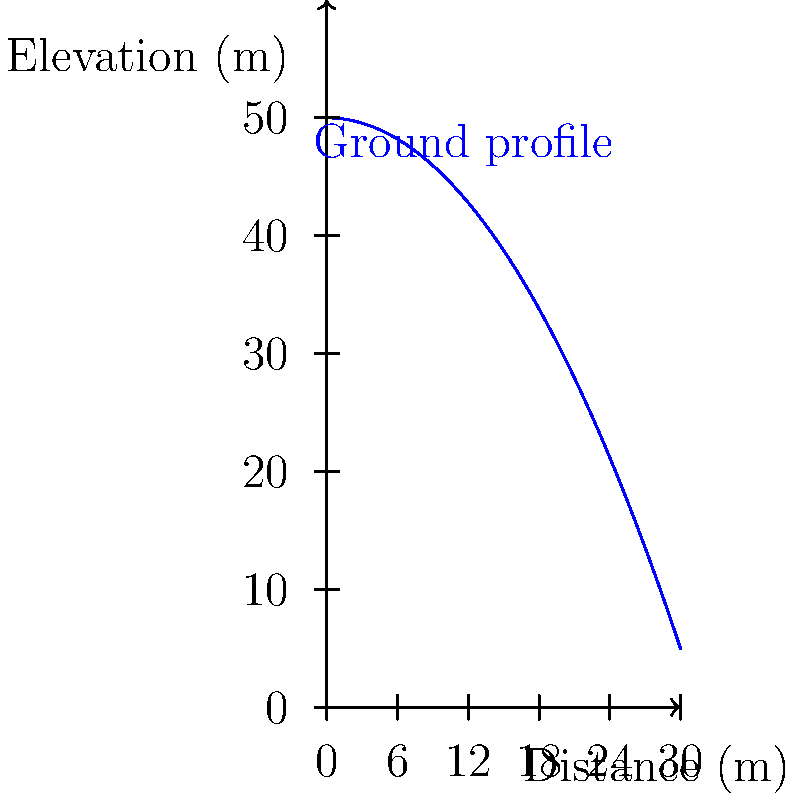A section of the Qosh Tepa Canal needs to be excavated. The longitudinal profile of the ground is shown in the graph above. The canal will have a constant bottom width of 5 meters and side slopes of 1:1. If the canal needs to be excavated to a depth of 40 meters at the deepest point, what is the total volume of soil to be excavated for a 30-meter long section of the canal? To calculate the volume of soil to be excavated, we need to follow these steps:

1) The ground profile is given by the equation: $y = 50 - 0.05x^2$

2) The canal bottom is 40 meters below the highest point, so its equation is: $y = 10$

3) We need to find the area between these two curves:
   $A = \int_0^{30} (50 - 0.05x^2 - 10) dx$
   $A = \int_0^{30} (40 - 0.05x^2) dx$
   $A = [40x - \frac{0.05x^3}{3}]_0^{30}$
   $A = (1200 - 450) - 0 = 750$ square meters

4) This is the cross-sectional area at the deepest point. The average cross-sectional area will be half of this: 375 square meters

5) The volume of a prismoidal shape (like our canal section) is given by the average cross-sectional area multiplied by the length:
   $V = 375 * 30 = 11,250$ cubic meters

6) However, this is just the rectangular part. We need to add the volume of the triangular sections on each side due to the 1:1 slope.

7) The additional triangular area on each side is:
   $A_{triangle} = \frac{1}{2} * 40 * 40 = 800$ square meters

8) This additional volume is:
   $V_{additional} = 800 * 30 = 24,000$ cubic meters

9) The total volume is therefore:
   $V_{total} = 11,250 + 24,000 = 35,250$ cubic meters
Answer: 35,250 cubic meters 